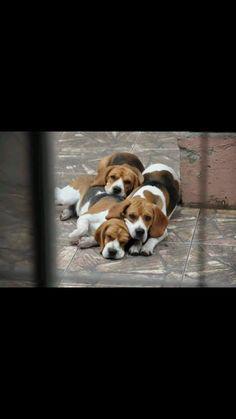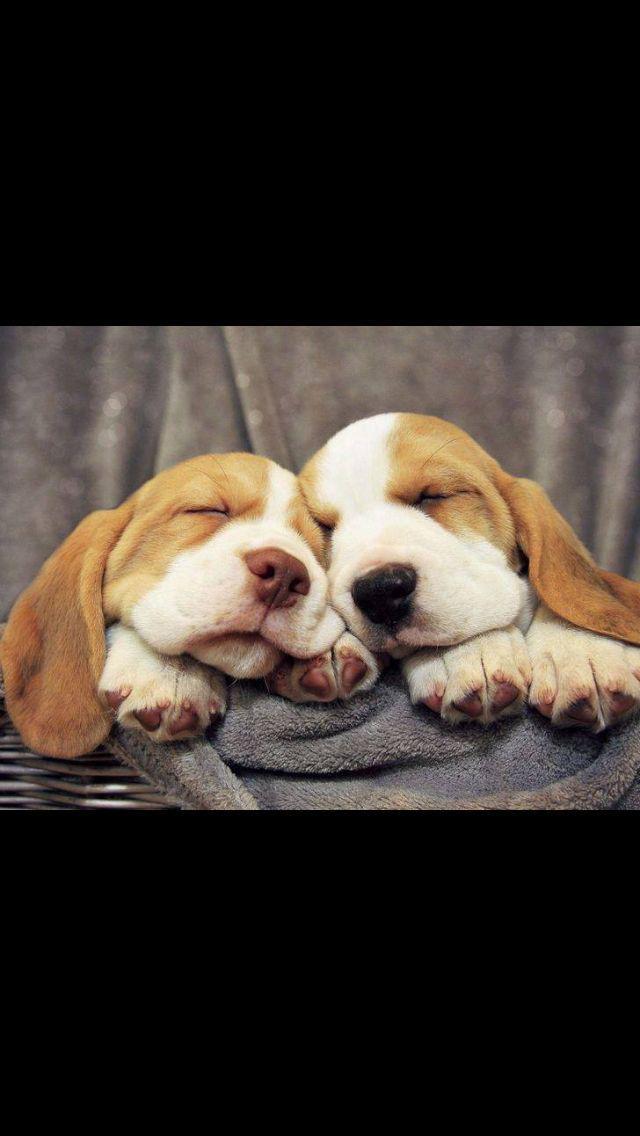The first image is the image on the left, the second image is the image on the right. Considering the images on both sides, is "Right image shows beagles sleeping in a soft-sided roundish pet bed." valid? Answer yes or no. No. The first image is the image on the left, the second image is the image on the right. Examine the images to the left and right. Is the description "Two dogs are sleeping together in one of the images." accurate? Answer yes or no. Yes. 